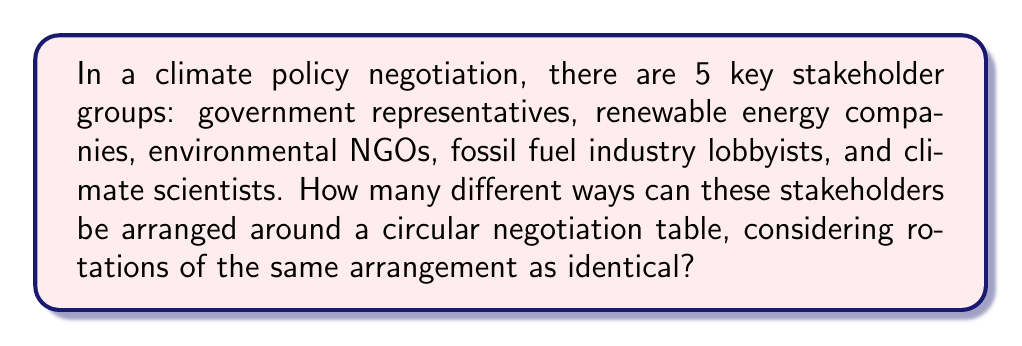Solve this math problem. To solve this problem, we need to use the concept of circular permutations. Here's the step-by-step explanation:

1) In a regular permutation, we would have 5! ways to arrange 5 stakeholders. However, in a circular arrangement, rotations of the same arrangement are considered identical.

2) For circular permutations, we use the formula:
   $$(n-1)!$$
   where $n$ is the number of elements to be arranged.

3) In this case, $n = 5$ (5 stakeholder groups).

4) Plugging this into our formula:
   $$(5-1)! = 4!$$

5) Calculate 4!:
   $$4! = 4 \times 3 \times 2 \times 1 = 24$$

Therefore, there are 24 different ways to arrange these 5 stakeholder groups around a circular negotiation table.

This arrangement allows for various interactions between adjacent stakeholders, which could significantly influence the dynamics and outcomes of the climate policy negotiation. For instance, having government representatives seated next to renewable energy companies might lead to different discussions compared to having them next to fossil fuel industry lobbyists.
Answer: 24 different arrangements 